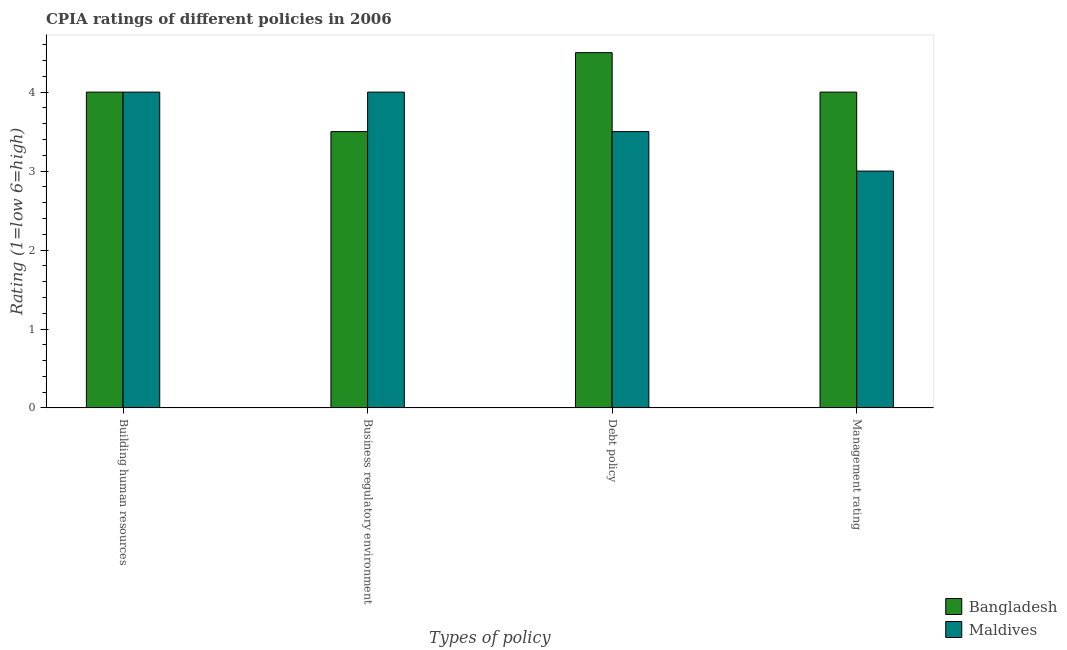How many different coloured bars are there?
Your answer should be compact. 2. How many groups of bars are there?
Keep it short and to the point. 4. Are the number of bars per tick equal to the number of legend labels?
Provide a succinct answer. Yes. Are the number of bars on each tick of the X-axis equal?
Ensure brevity in your answer.  Yes. How many bars are there on the 4th tick from the right?
Provide a succinct answer. 2. What is the label of the 3rd group of bars from the left?
Make the answer very short. Debt policy. What is the cpia rating of management in Maldives?
Provide a succinct answer. 3. In which country was the cpia rating of business regulatory environment maximum?
Provide a short and direct response. Maldives. In which country was the cpia rating of management minimum?
Provide a short and direct response. Maldives. What is the total cpia rating of management in the graph?
Give a very brief answer. 7. What is the difference between the cpia rating of debt policy in Maldives and that in Bangladesh?
Your answer should be compact. -1. What is the difference between the cpia rating of building human resources and cpia rating of debt policy in Maldives?
Give a very brief answer. 0.5. In how many countries, is the cpia rating of building human resources greater than 2 ?
Offer a terse response. 2. What is the ratio of the cpia rating of building human resources in Maldives to that in Bangladesh?
Your response must be concise. 1. Is the cpia rating of debt policy in Maldives less than that in Bangladesh?
Offer a very short reply. Yes. Is the difference between the cpia rating of business regulatory environment in Maldives and Bangladesh greater than the difference between the cpia rating of management in Maldives and Bangladesh?
Offer a terse response. Yes. Is the sum of the cpia rating of debt policy in Maldives and Bangladesh greater than the maximum cpia rating of management across all countries?
Your answer should be compact. Yes. What does the 2nd bar from the left in Management rating represents?
Make the answer very short. Maldives. What does the 1st bar from the right in Debt policy represents?
Your answer should be very brief. Maldives. Is it the case that in every country, the sum of the cpia rating of building human resources and cpia rating of business regulatory environment is greater than the cpia rating of debt policy?
Your response must be concise. Yes. How many bars are there?
Your response must be concise. 8. How many countries are there in the graph?
Provide a succinct answer. 2. Does the graph contain any zero values?
Make the answer very short. No. Does the graph contain grids?
Provide a short and direct response. No. Where does the legend appear in the graph?
Your response must be concise. Bottom right. How are the legend labels stacked?
Provide a succinct answer. Vertical. What is the title of the graph?
Give a very brief answer. CPIA ratings of different policies in 2006. Does "Jordan" appear as one of the legend labels in the graph?
Offer a very short reply. No. What is the label or title of the X-axis?
Your answer should be compact. Types of policy. What is the label or title of the Y-axis?
Keep it short and to the point. Rating (1=low 6=high). What is the Rating (1=low 6=high) in Bangladesh in Building human resources?
Make the answer very short. 4. What is the Rating (1=low 6=high) of Maldives in Management rating?
Your response must be concise. 3. Across all Types of policy, what is the minimum Rating (1=low 6=high) in Bangladesh?
Provide a succinct answer. 3.5. What is the difference between the Rating (1=low 6=high) in Maldives in Building human resources and that in Debt policy?
Give a very brief answer. 0.5. What is the difference between the Rating (1=low 6=high) in Bangladesh in Building human resources and that in Management rating?
Provide a short and direct response. 0. What is the difference between the Rating (1=low 6=high) of Bangladesh in Business regulatory environment and that in Management rating?
Ensure brevity in your answer.  -0.5. What is the difference between the Rating (1=low 6=high) in Maldives in Business regulatory environment and that in Management rating?
Offer a terse response. 1. What is the difference between the Rating (1=low 6=high) in Bangladesh in Debt policy and that in Management rating?
Provide a short and direct response. 0.5. What is the difference between the Rating (1=low 6=high) in Bangladesh in Building human resources and the Rating (1=low 6=high) in Maldives in Business regulatory environment?
Provide a short and direct response. 0. What is the difference between the Rating (1=low 6=high) of Bangladesh in Building human resources and the Rating (1=low 6=high) of Maldives in Management rating?
Your answer should be very brief. 1. What is the difference between the Rating (1=low 6=high) in Bangladesh in Business regulatory environment and the Rating (1=low 6=high) in Maldives in Debt policy?
Offer a terse response. 0. What is the difference between the Rating (1=low 6=high) of Bangladesh in Debt policy and the Rating (1=low 6=high) of Maldives in Management rating?
Keep it short and to the point. 1.5. What is the average Rating (1=low 6=high) of Maldives per Types of policy?
Keep it short and to the point. 3.62. What is the difference between the Rating (1=low 6=high) of Bangladesh and Rating (1=low 6=high) of Maldives in Building human resources?
Your response must be concise. 0. What is the difference between the Rating (1=low 6=high) in Bangladesh and Rating (1=low 6=high) in Maldives in Business regulatory environment?
Your answer should be very brief. -0.5. What is the ratio of the Rating (1=low 6=high) of Bangladesh in Building human resources to that in Business regulatory environment?
Your response must be concise. 1.14. What is the ratio of the Rating (1=low 6=high) in Maldives in Building human resources to that in Business regulatory environment?
Ensure brevity in your answer.  1. What is the ratio of the Rating (1=low 6=high) of Bangladesh in Building human resources to that in Debt policy?
Keep it short and to the point. 0.89. What is the ratio of the Rating (1=low 6=high) of Maldives in Building human resources to that in Debt policy?
Your answer should be compact. 1.14. What is the ratio of the Rating (1=low 6=high) in Maldives in Building human resources to that in Management rating?
Provide a succinct answer. 1.33. What is the ratio of the Rating (1=low 6=high) in Bangladesh in Business regulatory environment to that in Debt policy?
Offer a very short reply. 0.78. What is the ratio of the Rating (1=low 6=high) in Maldives in Business regulatory environment to that in Management rating?
Give a very brief answer. 1.33. What is the ratio of the Rating (1=low 6=high) of Bangladesh in Debt policy to that in Management rating?
Provide a short and direct response. 1.12. What is the ratio of the Rating (1=low 6=high) of Maldives in Debt policy to that in Management rating?
Your response must be concise. 1.17. What is the difference between the highest and the second highest Rating (1=low 6=high) of Bangladesh?
Your answer should be very brief. 0.5. What is the difference between the highest and the lowest Rating (1=low 6=high) in Maldives?
Provide a succinct answer. 1. 